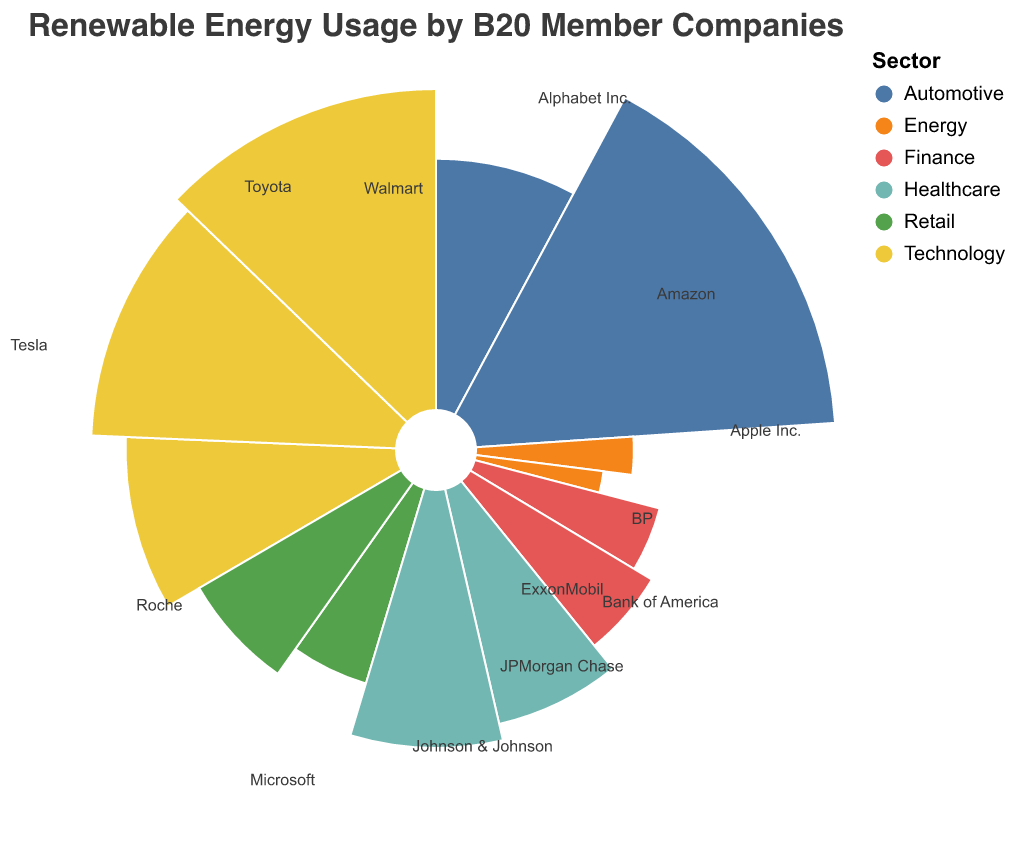What is the title of the chart? The title is displayed at the top of the chart. It reads "Renewable Energy Usage by B20 Member Companies".
Answer: Renewable Energy Usage by B20 Member Companies Which sector has the highest percentage of renewable energy usage? Tesla from the Automotive sector has the highest renewable energy percentage at 78%.
Answer: Automotive How much renewable energy does Microsoft use? Find the text label for Microsoft in the Technology sector and observe the corresponding percentage.
Answer: 56% What is the average renewable energy usage percentage of companies in the Finance sector? The renewable energy usage percentages for Finance companies are 22% (JPMorgan Chase) and 27% (Bank of America). The average is (22 + 27) / 2 = 24.5%.
Answer: 24.5% Which company in the Energy sector uses the least renewable energy? Compare the renewable energy percentages for BP (15%) and ExxonMobil (10%). ExxonMobil uses the least at 10%.
Answer: ExxonMobil Is the renewable energy usage of Walmart higher than Amazon? Compare the renewable energy percentages for Walmart (25%) and Amazon (33%) in the Retail sector. Walmart’s percentage is lower than Amazon’s.
Answer: No Which sectors have a company with renewable energy usage below 20%? Observe the data points and text labels to find companies with renewable energy percentages below 20%, which are BP (15%) and ExxonMobil (10%) in the Energy sector.
Answer: Energy How does the renewable energy usage of Toyota compare to Johnson & Johnson? Compare the renewable energy percentage for Toyota (38%) in the Automotive sector with Johnson & Johnson (35%) in the Healthcare sector. Toyota’s percentage is slightly higher.
Answer: Toyota is higher What is the total renewable energy percentage for all companies in the Technology sector? Add the renewable energy percentages for companies in the Technology sector: Apple Inc. (44%), Microsoft (56%), and Alphabet Inc. (62%). The total is 44 + 56 + 62 = 162%.
Answer: 162% Which company in the Healthcare sector has a higher renewable energy percentage? Compare the renewable energy percentages for Johnson & Johnson (35%) and Roche (40%) in the Healthcare sector. Roche has a higher percentage.
Answer: Roche 